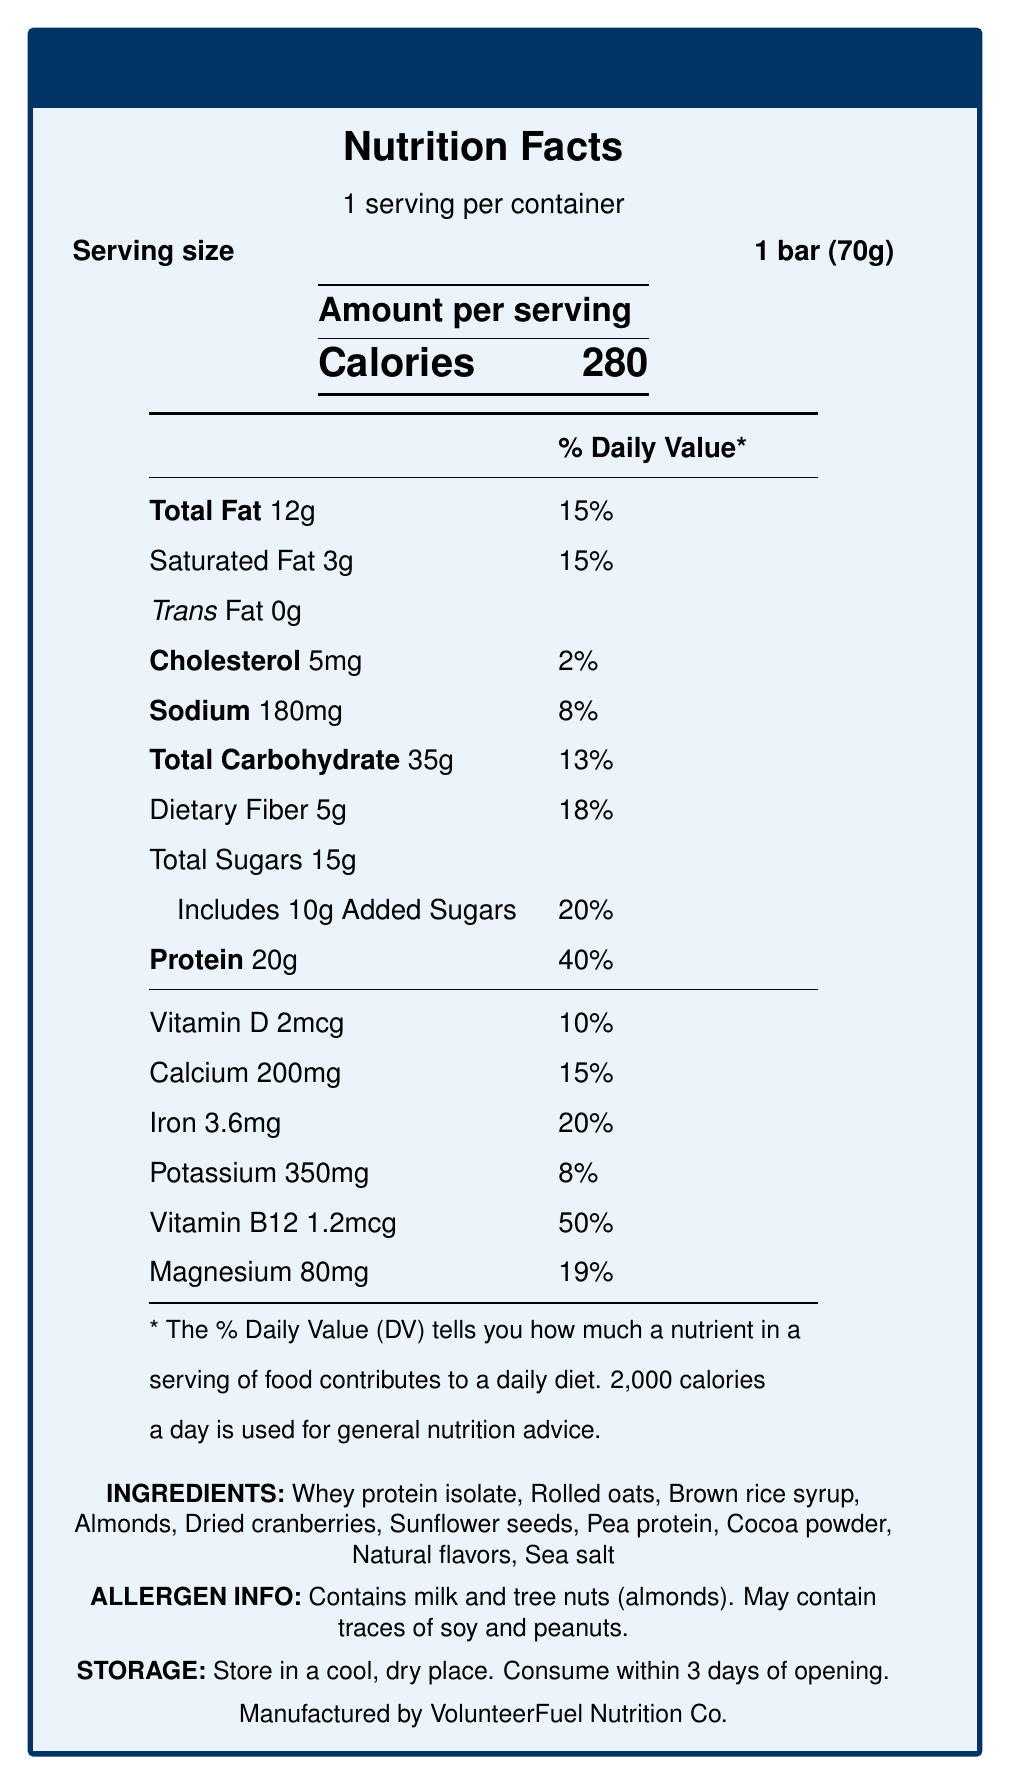what is the serving size? The serving size is mentioned next to "Serving size" in the document.
Answer: 1 bar (70g) what is the total amount of added sugars per serving? The document states "Includes 10g Added Sugars".
Answer: 10g How much protein does the PowerVol Energy Bar have? The protein content is listed as 20g in the document.
Answer: 20g Which allergen is contained in the PowerVol Energy Bar? The allergen information specifies "Contains milk and tree nuts (almonds)".
Answer: Milk and tree nuts (almonds) What is the recommended storage condition for the PowerVol Energy Bar? The storage instructions state "Store in a cool, dry place".
Answer: Store in a cool, dry place How many calories are in one serving of the PowerVol Energy Bar? The document states that one serving contains 280 calories.
Answer: 280 What percentage of the daily value for iron does the bar provide? The document lists the iron daily value as 20%.
Answer: 20% what is the main source of protein in the PowerVol Energy Bar? A. Pea protein B. Whey protein isolate C. Almonds D. Sunflower seeds The primary protein source listed in the ingredients is "Whey protein isolate".
Answer: B What is the amount of magnesium per serving? A. 50mg B. 80mg C. 100mg D. 120mg The amount of magnesium per serving is 80mg, as listed in the document.
Answer: B Are trans fats present in the PowerVol Energy Bar? The document states "Trans Fat 0g", indicating no trans fats are present.
Answer: No Summarize the key nutrients provided by the PowerVol Energy Bar. This summary encapsulates the main nutritional components and their amounts as provided in the document.
Answer: The PowerVol Energy Bar offers 280 calories, 12g of total fat, 3g of saturated fat, 0g trans fat, 5mg cholesterol, 180mg sodium, 35g total carbohydrates, 5g dietary fiber, 15g total sugars, including 10g added sugars, and 20g protein. It also provides Vitamin D, Calcium, Iron, Potassium, Vitamin B12, and Magnesium in varying percentages of daily value. What is the main purpose of the PowerVol Energy Bar being formulated? The product description explicitly mentions this purpose.
Answer: To provide sustained energy and essential nutrients for volunteers working long hours on equipment refurbishment projects. What are the key benefits of the PowerVol Energy Bar? The key benefits are clearly listed under "key benefits" in the document.
Answer: 20g of protein for muscle recovery and sustained energy, complex carbohydrates for long-lasting fuel, added B12 for increased energy and focus, rich in fiber to promote satiety, and fortified with essential vitamins and minerals. What company manufactures the PowerVol Energy Bar? The document states "Manufactured by VolunteerFuel Nutrition Co."
Answer: VolunteerFuel Nutrition Co. How many days after opening should the PowerVol Energy Bar be consumed? The storage instructions specify "Consume within 3 days of opening."
Answer: Within 3 days Is the PowerVol Energy Bar suitable for individuals with peanut allergies? The allergen information indicates it may contain traces of peanuts, but does not definitively state suitability for those with peanut allergies.
Answer: Not enough information 